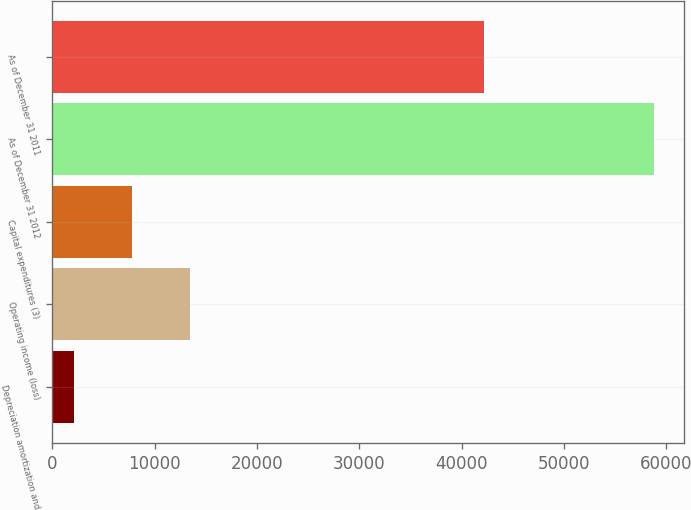<chart> <loc_0><loc_0><loc_500><loc_500><bar_chart><fcel>Depreciation amortization and<fcel>Operating income (loss)<fcel>Capital expenditures (3)<fcel>As of December 31 2012<fcel>As of December 31 2011<nl><fcel>2118<fcel>13455.2<fcel>7786.6<fcel>58804<fcel>42164<nl></chart> 